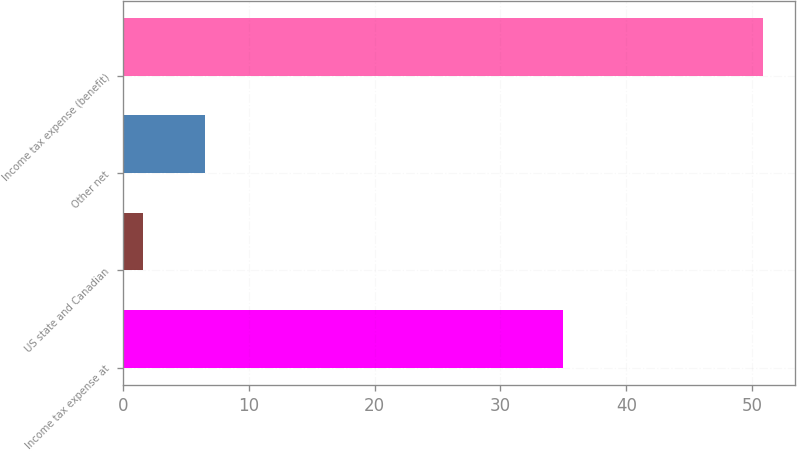Convert chart. <chart><loc_0><loc_0><loc_500><loc_500><bar_chart><fcel>Income tax expense at<fcel>US state and Canadian<fcel>Other net<fcel>Income tax expense (benefit)<nl><fcel>35<fcel>1.6<fcel>6.53<fcel>50.9<nl></chart> 